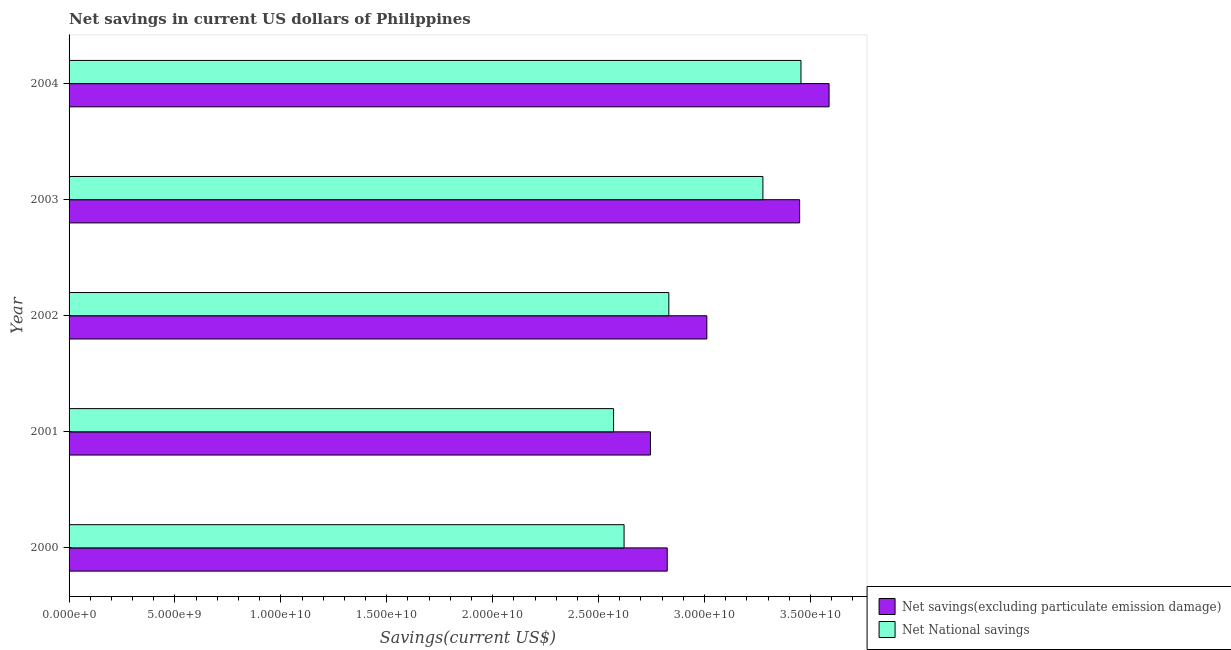How many different coloured bars are there?
Provide a short and direct response. 2. Are the number of bars on each tick of the Y-axis equal?
Your answer should be very brief. Yes. What is the net savings(excluding particulate emission damage) in 2000?
Make the answer very short. 2.82e+1. Across all years, what is the maximum net national savings?
Your answer should be compact. 3.46e+1. Across all years, what is the minimum net savings(excluding particulate emission damage)?
Make the answer very short. 2.74e+1. In which year was the net savings(excluding particulate emission damage) maximum?
Give a very brief answer. 2004. In which year was the net national savings minimum?
Make the answer very short. 2001. What is the total net savings(excluding particulate emission damage) in the graph?
Ensure brevity in your answer.  1.56e+11. What is the difference between the net savings(excluding particulate emission damage) in 2002 and that in 2004?
Offer a very short reply. -5.77e+09. What is the difference between the net savings(excluding particulate emission damage) in 2002 and the net national savings in 2003?
Provide a short and direct response. -2.65e+09. What is the average net savings(excluding particulate emission damage) per year?
Offer a very short reply. 3.12e+1. In the year 2003, what is the difference between the net savings(excluding particulate emission damage) and net national savings?
Offer a very short reply. 1.73e+09. In how many years, is the net national savings greater than 5000000000 US$?
Your response must be concise. 5. What is the ratio of the net savings(excluding particulate emission damage) in 2000 to that in 2002?
Your answer should be compact. 0.94. Is the difference between the net savings(excluding particulate emission damage) in 2002 and 2004 greater than the difference between the net national savings in 2002 and 2004?
Ensure brevity in your answer.  Yes. What is the difference between the highest and the second highest net savings(excluding particulate emission damage)?
Give a very brief answer. 1.39e+09. What is the difference between the highest and the lowest net savings(excluding particulate emission damage)?
Your answer should be compact. 8.43e+09. In how many years, is the net national savings greater than the average net national savings taken over all years?
Keep it short and to the point. 2. What does the 2nd bar from the top in 2002 represents?
Make the answer very short. Net savings(excluding particulate emission damage). What does the 2nd bar from the bottom in 2001 represents?
Provide a succinct answer. Net National savings. How many bars are there?
Your answer should be very brief. 10. Does the graph contain any zero values?
Ensure brevity in your answer.  No. Does the graph contain grids?
Make the answer very short. No. Where does the legend appear in the graph?
Provide a succinct answer. Bottom right. How many legend labels are there?
Make the answer very short. 2. How are the legend labels stacked?
Your answer should be very brief. Vertical. What is the title of the graph?
Ensure brevity in your answer.  Net savings in current US dollars of Philippines. Does "RDB concessional" appear as one of the legend labels in the graph?
Offer a terse response. No. What is the label or title of the X-axis?
Make the answer very short. Savings(current US$). What is the Savings(current US$) in Net savings(excluding particulate emission damage) in 2000?
Provide a succinct answer. 2.82e+1. What is the Savings(current US$) in Net National savings in 2000?
Keep it short and to the point. 2.62e+1. What is the Savings(current US$) in Net savings(excluding particulate emission damage) in 2001?
Keep it short and to the point. 2.74e+1. What is the Savings(current US$) in Net National savings in 2001?
Provide a short and direct response. 2.57e+1. What is the Savings(current US$) of Net savings(excluding particulate emission damage) in 2002?
Keep it short and to the point. 3.01e+1. What is the Savings(current US$) of Net National savings in 2002?
Your answer should be very brief. 2.83e+1. What is the Savings(current US$) in Net savings(excluding particulate emission damage) in 2003?
Keep it short and to the point. 3.45e+1. What is the Savings(current US$) of Net National savings in 2003?
Provide a short and direct response. 3.28e+1. What is the Savings(current US$) in Net savings(excluding particulate emission damage) in 2004?
Your answer should be compact. 3.59e+1. What is the Savings(current US$) of Net National savings in 2004?
Your response must be concise. 3.46e+1. Across all years, what is the maximum Savings(current US$) of Net savings(excluding particulate emission damage)?
Your response must be concise. 3.59e+1. Across all years, what is the maximum Savings(current US$) of Net National savings?
Your response must be concise. 3.46e+1. Across all years, what is the minimum Savings(current US$) in Net savings(excluding particulate emission damage)?
Offer a very short reply. 2.74e+1. Across all years, what is the minimum Savings(current US$) in Net National savings?
Offer a very short reply. 2.57e+1. What is the total Savings(current US$) in Net savings(excluding particulate emission damage) in the graph?
Your response must be concise. 1.56e+11. What is the total Savings(current US$) of Net National savings in the graph?
Ensure brevity in your answer.  1.48e+11. What is the difference between the Savings(current US$) of Net savings(excluding particulate emission damage) in 2000 and that in 2001?
Ensure brevity in your answer.  7.92e+08. What is the difference between the Savings(current US$) of Net National savings in 2000 and that in 2001?
Ensure brevity in your answer.  4.96e+08. What is the difference between the Savings(current US$) of Net savings(excluding particulate emission damage) in 2000 and that in 2002?
Your response must be concise. -1.87e+09. What is the difference between the Savings(current US$) of Net National savings in 2000 and that in 2002?
Keep it short and to the point. -2.11e+09. What is the difference between the Savings(current US$) of Net savings(excluding particulate emission damage) in 2000 and that in 2003?
Give a very brief answer. -6.25e+09. What is the difference between the Savings(current US$) of Net National savings in 2000 and that in 2003?
Give a very brief answer. -6.55e+09. What is the difference between the Savings(current US$) in Net savings(excluding particulate emission damage) in 2000 and that in 2004?
Your response must be concise. -7.64e+09. What is the difference between the Savings(current US$) in Net National savings in 2000 and that in 2004?
Make the answer very short. -8.35e+09. What is the difference between the Savings(current US$) in Net savings(excluding particulate emission damage) in 2001 and that in 2002?
Keep it short and to the point. -2.66e+09. What is the difference between the Savings(current US$) in Net National savings in 2001 and that in 2002?
Your answer should be compact. -2.61e+09. What is the difference between the Savings(current US$) of Net savings(excluding particulate emission damage) in 2001 and that in 2003?
Your answer should be compact. -7.04e+09. What is the difference between the Savings(current US$) of Net National savings in 2001 and that in 2003?
Your response must be concise. -7.05e+09. What is the difference between the Savings(current US$) of Net savings(excluding particulate emission damage) in 2001 and that in 2004?
Your answer should be very brief. -8.43e+09. What is the difference between the Savings(current US$) of Net National savings in 2001 and that in 2004?
Keep it short and to the point. -8.85e+09. What is the difference between the Savings(current US$) in Net savings(excluding particulate emission damage) in 2002 and that in 2003?
Provide a succinct answer. -4.38e+09. What is the difference between the Savings(current US$) of Net National savings in 2002 and that in 2003?
Make the answer very short. -4.44e+09. What is the difference between the Savings(current US$) in Net savings(excluding particulate emission damage) in 2002 and that in 2004?
Your response must be concise. -5.77e+09. What is the difference between the Savings(current US$) in Net National savings in 2002 and that in 2004?
Provide a succinct answer. -6.24e+09. What is the difference between the Savings(current US$) of Net savings(excluding particulate emission damage) in 2003 and that in 2004?
Keep it short and to the point. -1.39e+09. What is the difference between the Savings(current US$) of Net National savings in 2003 and that in 2004?
Your answer should be compact. -1.80e+09. What is the difference between the Savings(current US$) in Net savings(excluding particulate emission damage) in 2000 and the Savings(current US$) in Net National savings in 2001?
Offer a terse response. 2.53e+09. What is the difference between the Savings(current US$) of Net savings(excluding particulate emission damage) in 2000 and the Savings(current US$) of Net National savings in 2002?
Offer a terse response. -7.59e+07. What is the difference between the Savings(current US$) of Net savings(excluding particulate emission damage) in 2000 and the Savings(current US$) of Net National savings in 2003?
Your response must be concise. -4.52e+09. What is the difference between the Savings(current US$) of Net savings(excluding particulate emission damage) in 2000 and the Savings(current US$) of Net National savings in 2004?
Your answer should be compact. -6.31e+09. What is the difference between the Savings(current US$) of Net savings(excluding particulate emission damage) in 2001 and the Savings(current US$) of Net National savings in 2002?
Your response must be concise. -8.68e+08. What is the difference between the Savings(current US$) of Net savings(excluding particulate emission damage) in 2001 and the Savings(current US$) of Net National savings in 2003?
Give a very brief answer. -5.31e+09. What is the difference between the Savings(current US$) in Net savings(excluding particulate emission damage) in 2001 and the Savings(current US$) in Net National savings in 2004?
Your answer should be compact. -7.11e+09. What is the difference between the Savings(current US$) of Net savings(excluding particulate emission damage) in 2002 and the Savings(current US$) of Net National savings in 2003?
Ensure brevity in your answer.  -2.65e+09. What is the difference between the Savings(current US$) of Net savings(excluding particulate emission damage) in 2002 and the Savings(current US$) of Net National savings in 2004?
Offer a very short reply. -4.44e+09. What is the difference between the Savings(current US$) in Net savings(excluding particulate emission damage) in 2003 and the Savings(current US$) in Net National savings in 2004?
Offer a very short reply. -6.26e+07. What is the average Savings(current US$) in Net savings(excluding particulate emission damage) per year?
Keep it short and to the point. 3.12e+1. What is the average Savings(current US$) in Net National savings per year?
Keep it short and to the point. 2.95e+1. In the year 2000, what is the difference between the Savings(current US$) of Net savings(excluding particulate emission damage) and Savings(current US$) of Net National savings?
Make the answer very short. 2.04e+09. In the year 2001, what is the difference between the Savings(current US$) in Net savings(excluding particulate emission damage) and Savings(current US$) in Net National savings?
Keep it short and to the point. 1.74e+09. In the year 2002, what is the difference between the Savings(current US$) of Net savings(excluding particulate emission damage) and Savings(current US$) of Net National savings?
Provide a short and direct response. 1.79e+09. In the year 2003, what is the difference between the Savings(current US$) in Net savings(excluding particulate emission damage) and Savings(current US$) in Net National savings?
Give a very brief answer. 1.73e+09. In the year 2004, what is the difference between the Savings(current US$) in Net savings(excluding particulate emission damage) and Savings(current US$) in Net National savings?
Your answer should be compact. 1.33e+09. What is the ratio of the Savings(current US$) of Net savings(excluding particulate emission damage) in 2000 to that in 2001?
Your answer should be very brief. 1.03. What is the ratio of the Savings(current US$) of Net National savings in 2000 to that in 2001?
Make the answer very short. 1.02. What is the ratio of the Savings(current US$) of Net savings(excluding particulate emission damage) in 2000 to that in 2002?
Offer a very short reply. 0.94. What is the ratio of the Savings(current US$) of Net National savings in 2000 to that in 2002?
Make the answer very short. 0.93. What is the ratio of the Savings(current US$) of Net savings(excluding particulate emission damage) in 2000 to that in 2003?
Your response must be concise. 0.82. What is the ratio of the Savings(current US$) in Net National savings in 2000 to that in 2003?
Offer a terse response. 0.8. What is the ratio of the Savings(current US$) in Net savings(excluding particulate emission damage) in 2000 to that in 2004?
Your answer should be very brief. 0.79. What is the ratio of the Savings(current US$) in Net National savings in 2000 to that in 2004?
Offer a terse response. 0.76. What is the ratio of the Savings(current US$) of Net savings(excluding particulate emission damage) in 2001 to that in 2002?
Your response must be concise. 0.91. What is the ratio of the Savings(current US$) in Net National savings in 2001 to that in 2002?
Ensure brevity in your answer.  0.91. What is the ratio of the Savings(current US$) in Net savings(excluding particulate emission damage) in 2001 to that in 2003?
Keep it short and to the point. 0.8. What is the ratio of the Savings(current US$) in Net National savings in 2001 to that in 2003?
Give a very brief answer. 0.78. What is the ratio of the Savings(current US$) of Net savings(excluding particulate emission damage) in 2001 to that in 2004?
Ensure brevity in your answer.  0.77. What is the ratio of the Savings(current US$) of Net National savings in 2001 to that in 2004?
Give a very brief answer. 0.74. What is the ratio of the Savings(current US$) in Net savings(excluding particulate emission damage) in 2002 to that in 2003?
Make the answer very short. 0.87. What is the ratio of the Savings(current US$) in Net National savings in 2002 to that in 2003?
Provide a succinct answer. 0.86. What is the ratio of the Savings(current US$) of Net savings(excluding particulate emission damage) in 2002 to that in 2004?
Your answer should be compact. 0.84. What is the ratio of the Savings(current US$) of Net National savings in 2002 to that in 2004?
Provide a short and direct response. 0.82. What is the ratio of the Savings(current US$) of Net savings(excluding particulate emission damage) in 2003 to that in 2004?
Offer a terse response. 0.96. What is the ratio of the Savings(current US$) in Net National savings in 2003 to that in 2004?
Offer a terse response. 0.95. What is the difference between the highest and the second highest Savings(current US$) of Net savings(excluding particulate emission damage)?
Provide a succinct answer. 1.39e+09. What is the difference between the highest and the second highest Savings(current US$) of Net National savings?
Make the answer very short. 1.80e+09. What is the difference between the highest and the lowest Savings(current US$) of Net savings(excluding particulate emission damage)?
Keep it short and to the point. 8.43e+09. What is the difference between the highest and the lowest Savings(current US$) of Net National savings?
Keep it short and to the point. 8.85e+09. 